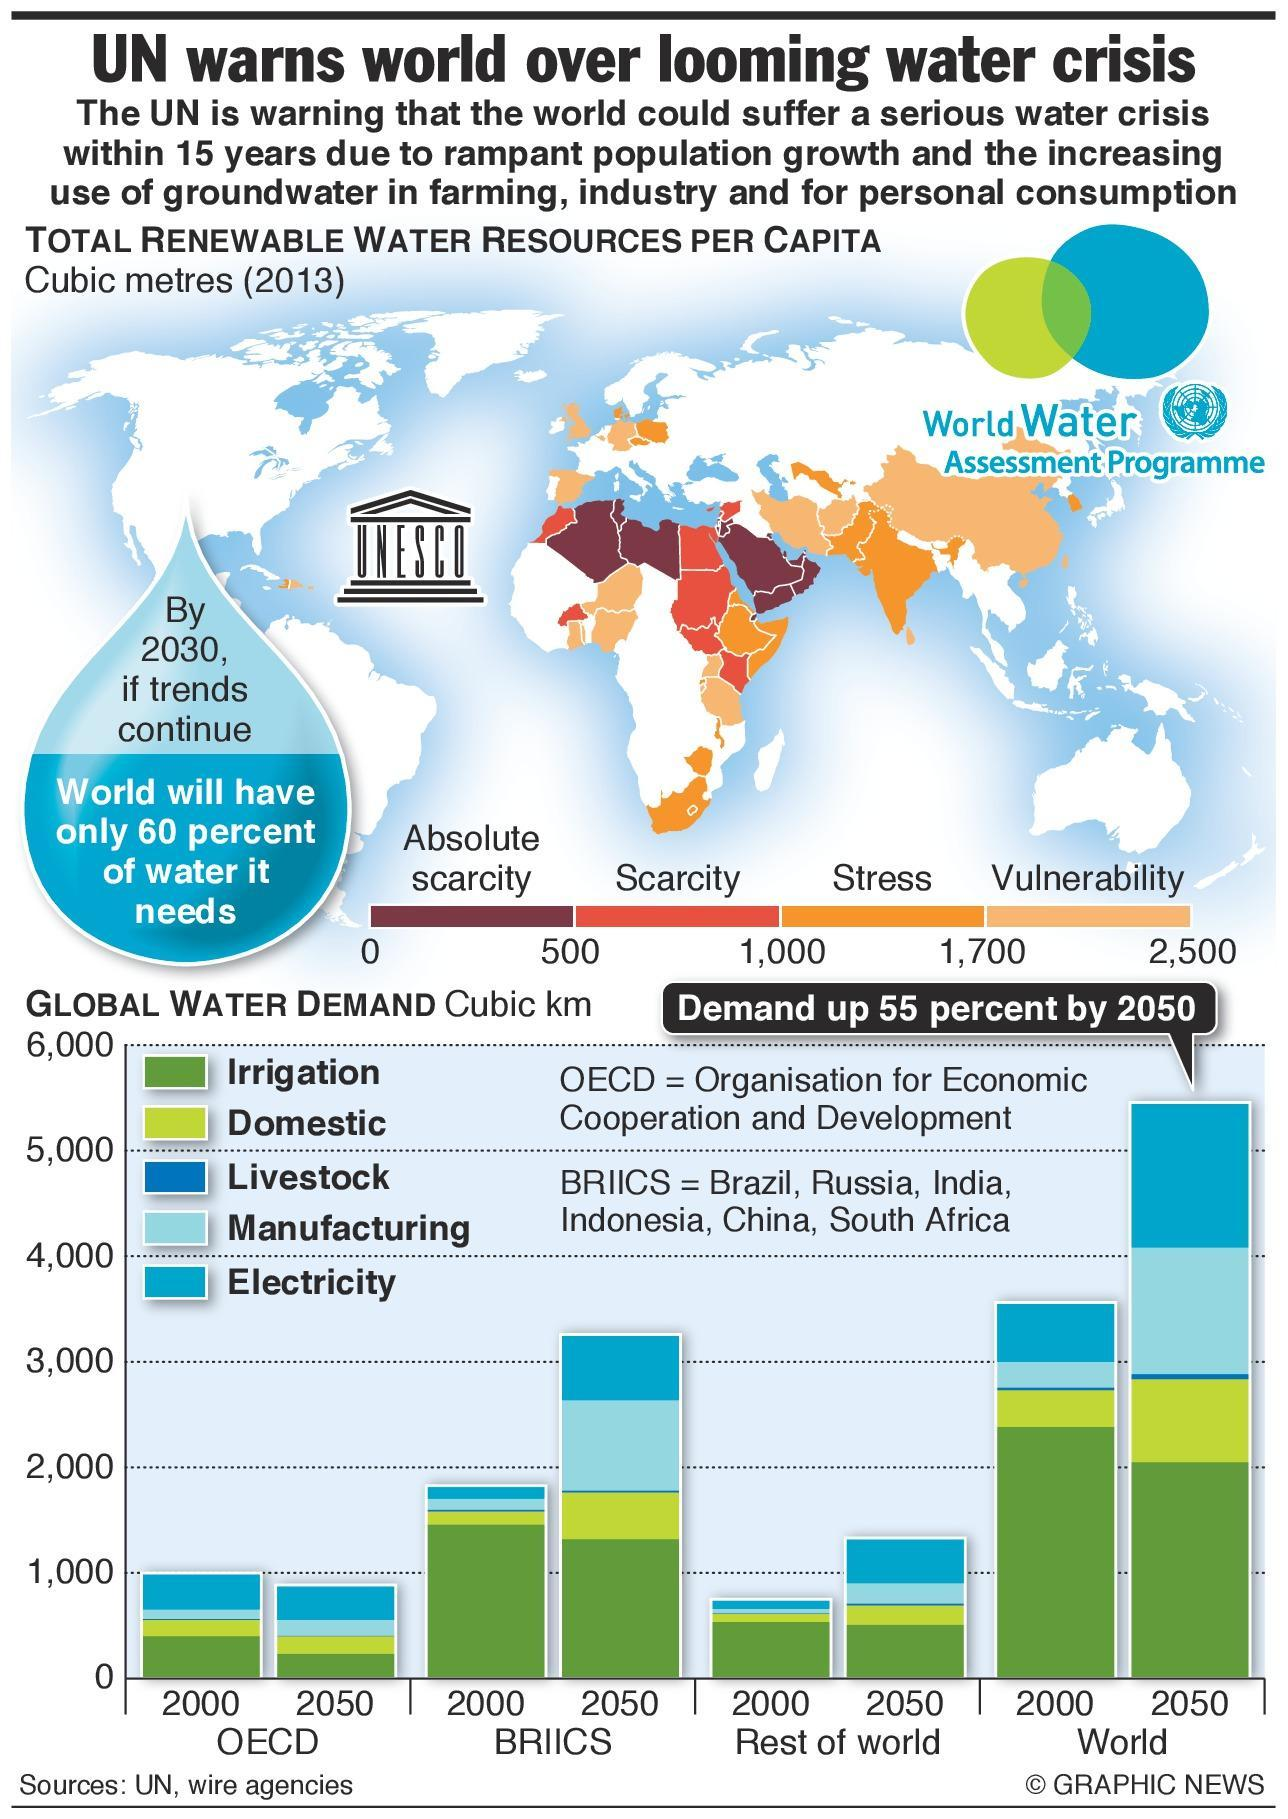How many countries in Northern region of Africa are likely to face absolute scarcity of water?
Answer the question with a short phrase. 3 Which continent has larger area vulnerable to face water crisis - Asia or Europe? Asia 